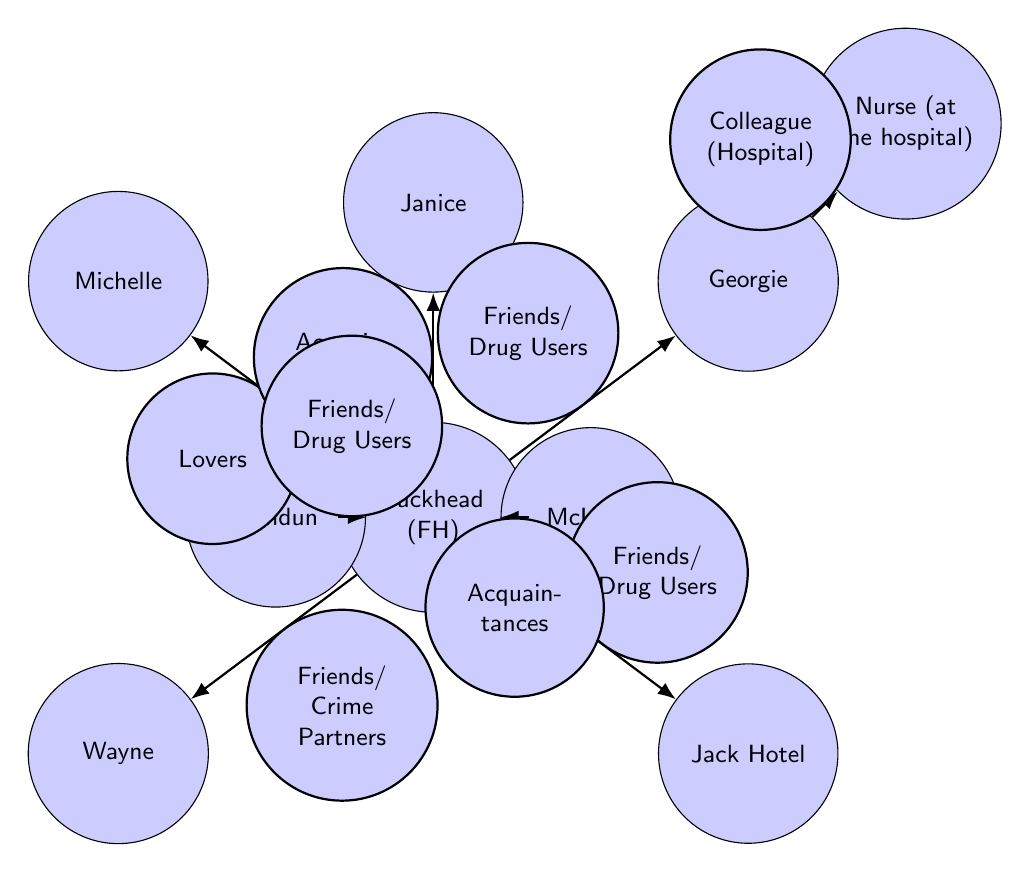What is the total number of characters in the diagram? Counting the nodes in the diagram, we have: Fuckhead, Michelle, Georgie, Wayne, Jack Hotel, Janice, Dundun, McInnes, and Nurse. This totals to 9 characters.
Answer: 9 What is the relationship between Fuckhead and Michelle? The edge connecting Fuckhead to Michelle is labeled "Lovers," indicating that their relationship is romantic.
Answer: Lovers Which character is connected to Fuckhead as an acquaintance? The edge from Fuckhead to McInnes is labeled "Acquaintances," showing that this is the correct relationship.
Answer: McInnes How many different types of relationships can be seen between Fuckhead and the other characters? The edges indicate multiple relationships: Lovers with Michelle, Friends/Drug Users with Georgie, Wayne, Jack Hotel, and Dundun, and Acquaintances with Janice and McInnes. This counts to 6 types.
Answer: 6 What is the title used to show the relationship between Georgie and Nurse? The edge between Georgie and Nurse is labeled "Colleague (Hospital)," describing their professional connection.
Answer: Colleague (Hospital) If a new character named "Sarah" were to be added as a lover to Fuckhead, how many relationships would Fuckhead have? Currently, Fuckhead has 6 relationships; adding Sarah would increase this count by 1, totaling 7 relationships.
Answer: 7 Which character is identified as a friend and a drug user of Fuckhead? There are multiple friends and drug users of Fuckhead; Georgie and Jack Hotel both share this relationship.
Answer: Georgie, Jack Hotel What type of diagram is this showing character interactions? This is a network diagram depicting character relationships and interactions in "Jesus' Son" by Denis Johnson.
Answer: Network diagram What connects Georgie to Nurse in the diagram? The connection is labeled with the relationship "Colleague (Hospital)," indicating their professional tie.
Answer: Colleague (Hospital) 